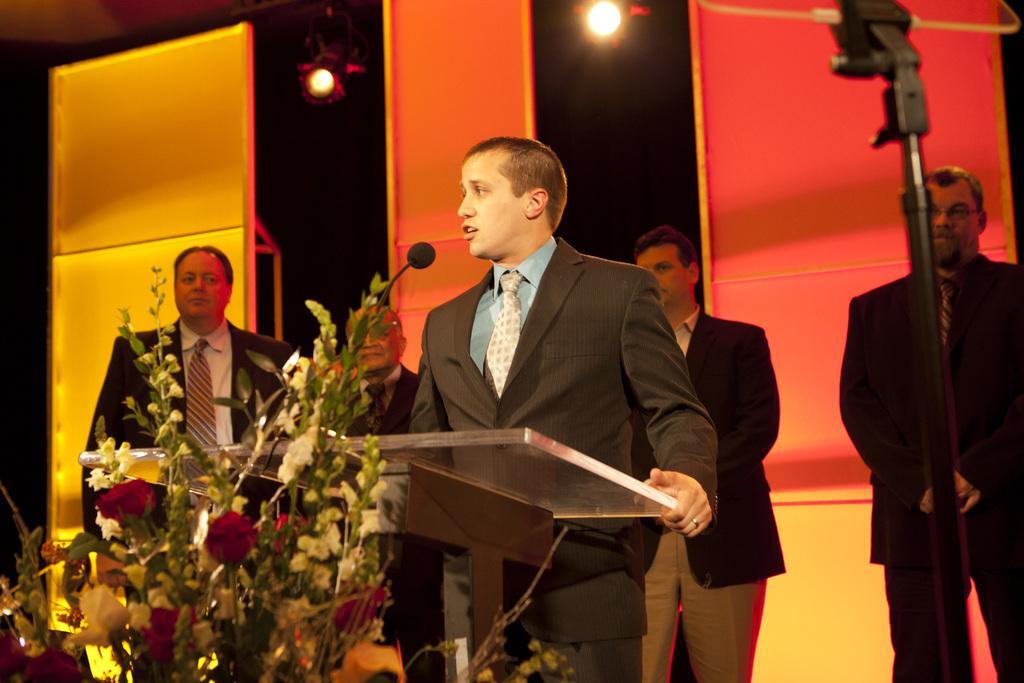Please provide a concise description of this image. Here I can see a man wearing a suit, standing in front of the podium and speaking on the microphone. On the left side there is a flower bouquet. At the back of this man four men are standing. At the back of these people I can see few boards. At the top there are two lights. On the right side there is a metal stand. 